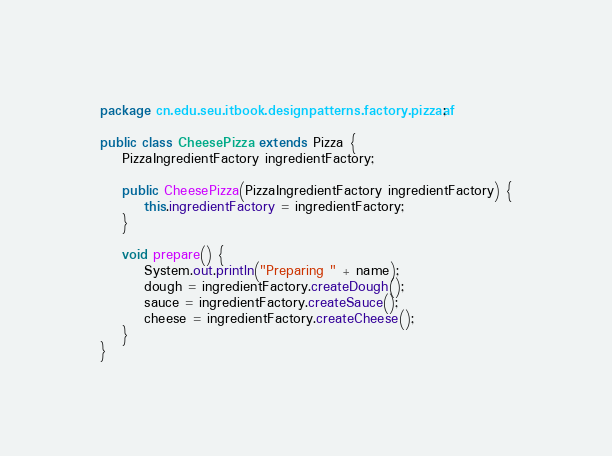Convert code to text. <code><loc_0><loc_0><loc_500><loc_500><_Java_>package cn.edu.seu.itbook.designpatterns.factory.pizzaaf;

public class CheesePizza extends Pizza {
	PizzaIngredientFactory ingredientFactory;
 
	public CheesePizza(PizzaIngredientFactory ingredientFactory) {
		this.ingredientFactory = ingredientFactory;
	}
 
	void prepare() {
		System.out.println("Preparing " + name);
		dough = ingredientFactory.createDough();
		sauce = ingredientFactory.createSauce();
		cheese = ingredientFactory.createCheese();
	}
}
</code> 